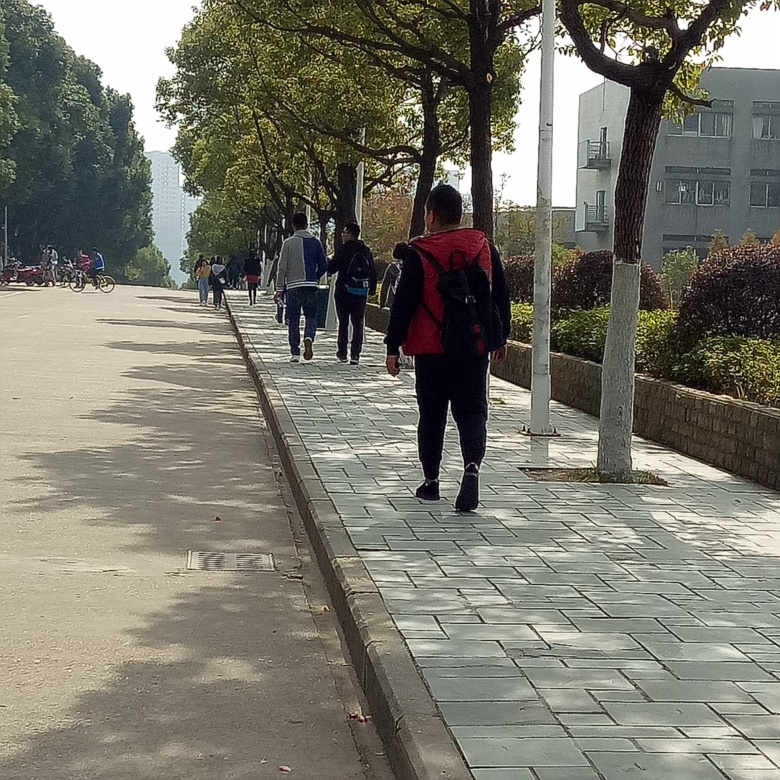Is the composition acceptable? The composition of the image is generally acceptable, with a balanced distribution of subjects along the sidewalk which draws the eye down the path. However, the framing could be improved by following the rule of thirds more closely and possibly by capturing a more symmetrical arrangement of the trees and the walkway to enhance the sense of depth and perspective. 